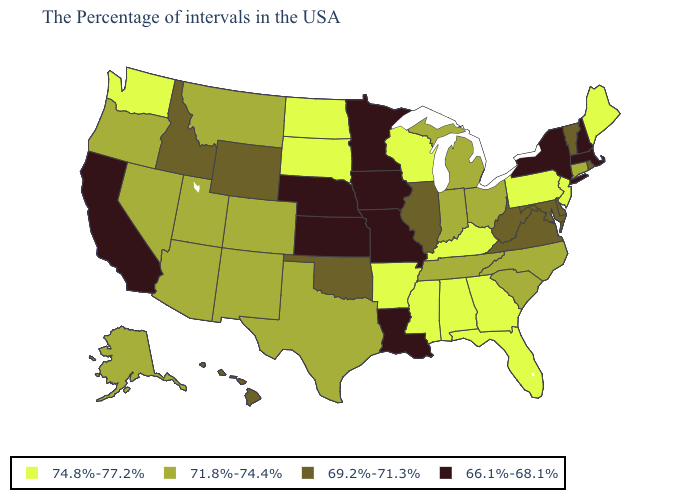What is the value of Indiana?
Write a very short answer. 71.8%-74.4%. What is the value of Georgia?
Concise answer only. 74.8%-77.2%. Among the states that border North Dakota , does Minnesota have the lowest value?
Answer briefly. Yes. Name the states that have a value in the range 66.1%-68.1%?
Short answer required. Massachusetts, New Hampshire, New York, Louisiana, Missouri, Minnesota, Iowa, Kansas, Nebraska, California. What is the value of Montana?
Short answer required. 71.8%-74.4%. Among the states that border Rhode Island , does Massachusetts have the highest value?
Be succinct. No. Does Georgia have the same value as Arizona?
Give a very brief answer. No. Among the states that border Wyoming , which have the lowest value?
Short answer required. Nebraska. Does North Dakota have the highest value in the MidWest?
Quick response, please. Yes. Does Hawaii have a higher value than Oregon?
Short answer required. No. Name the states that have a value in the range 74.8%-77.2%?
Keep it brief. Maine, New Jersey, Pennsylvania, Florida, Georgia, Kentucky, Alabama, Wisconsin, Mississippi, Arkansas, South Dakota, North Dakota, Washington. What is the value of Louisiana?
Give a very brief answer. 66.1%-68.1%. What is the value of Wyoming?
Quick response, please. 69.2%-71.3%. Does the first symbol in the legend represent the smallest category?
Short answer required. No. Does Oregon have the lowest value in the USA?
Answer briefly. No. 